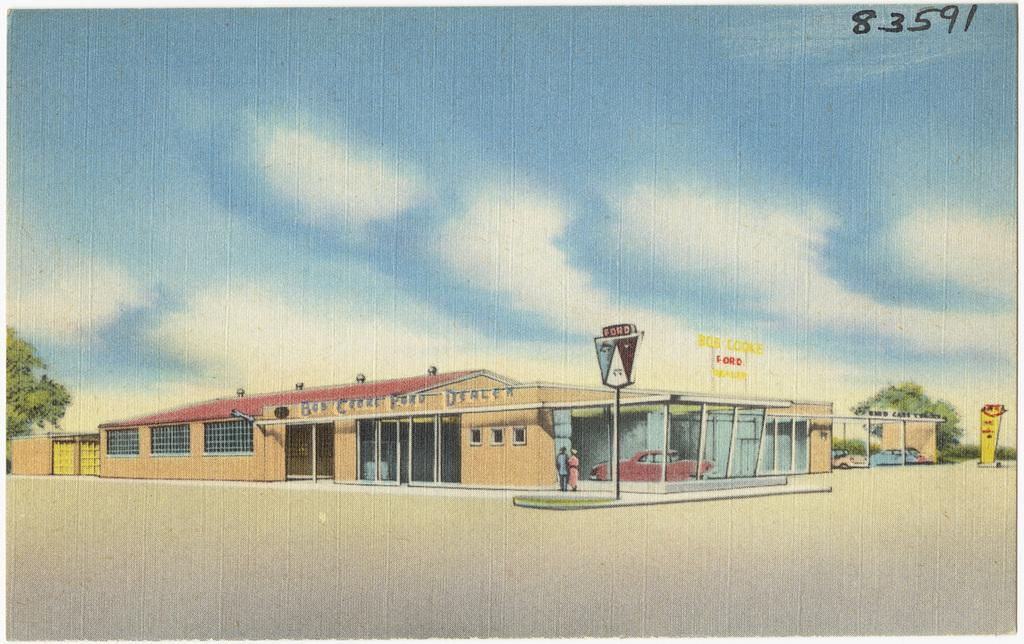<image>
Describe the image concisely. A car dealership has a Ford sign standing outside. 